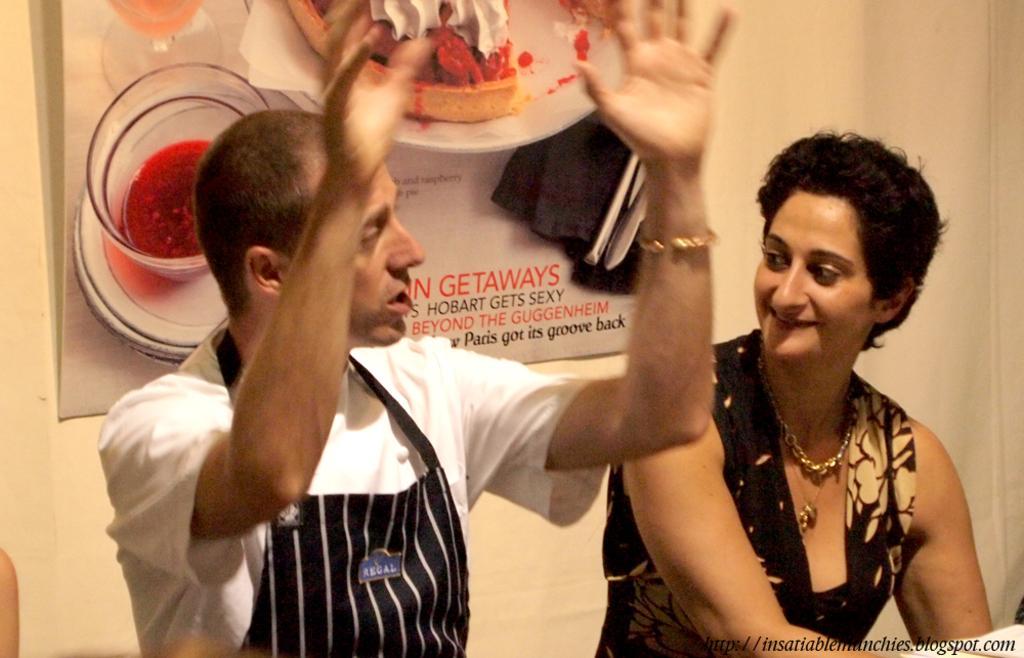Can you describe this image briefly? In the center of the image there is a man and woman sitting at the table. In the background we can see poster and wall. 